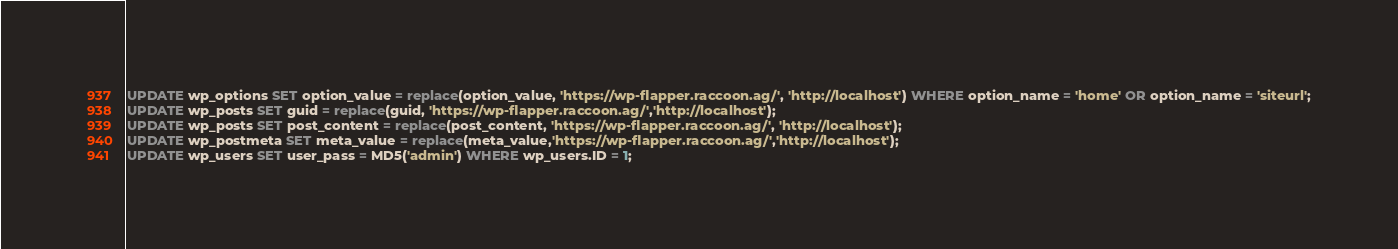Convert code to text. <code><loc_0><loc_0><loc_500><loc_500><_SQL_>UPDATE wp_options SET option_value = replace(option_value, 'https://wp-flapper.raccoon.ag/', 'http://localhost') WHERE option_name = 'home' OR option_name = 'siteurl';
UPDATE wp_posts SET guid = replace(guid, 'https://wp-flapper.raccoon.ag/','http://localhost');
UPDATE wp_posts SET post_content = replace(post_content, 'https://wp-flapper.raccoon.ag/', 'http://localhost');
UPDATE wp_postmeta SET meta_value = replace(meta_value,'https://wp-flapper.raccoon.ag/','http://localhost');
UPDATE wp_users SET user_pass = MD5('admin') WHERE wp_users.ID = 1;

</code> 